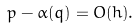Convert formula to latex. <formula><loc_0><loc_0><loc_500><loc_500>p - \alpha ( q ) = O ( h ) .</formula> 